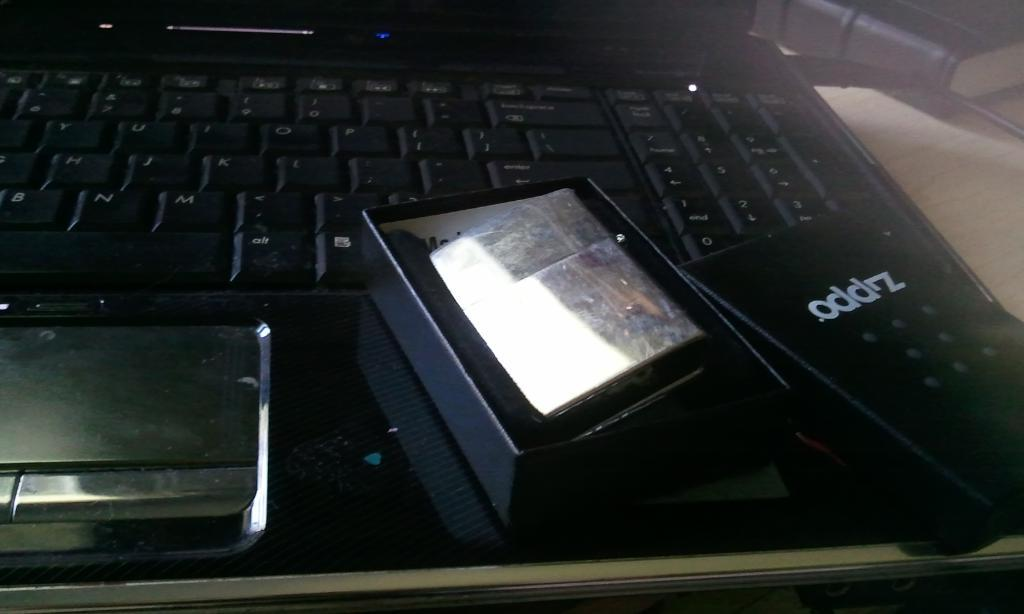<image>
Summarize the visual content of the image. A black laptop with a box that has oddrz written on it. 